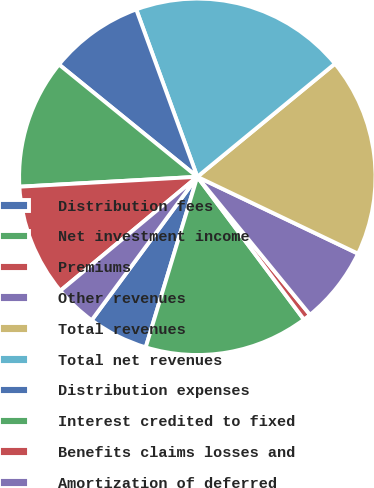<chart> <loc_0><loc_0><loc_500><loc_500><pie_chart><fcel>Distribution fees<fcel>Net investment income<fcel>Premiums<fcel>Other revenues<fcel>Total revenues<fcel>Total net revenues<fcel>Distribution expenses<fcel>Interest credited to fixed<fcel>Benefits claims losses and<fcel>Amortization of deferred<nl><fcel>5.43%<fcel>14.89%<fcel>0.69%<fcel>7.0%<fcel>18.05%<fcel>19.62%<fcel>8.58%<fcel>11.74%<fcel>10.16%<fcel>3.85%<nl></chart> 